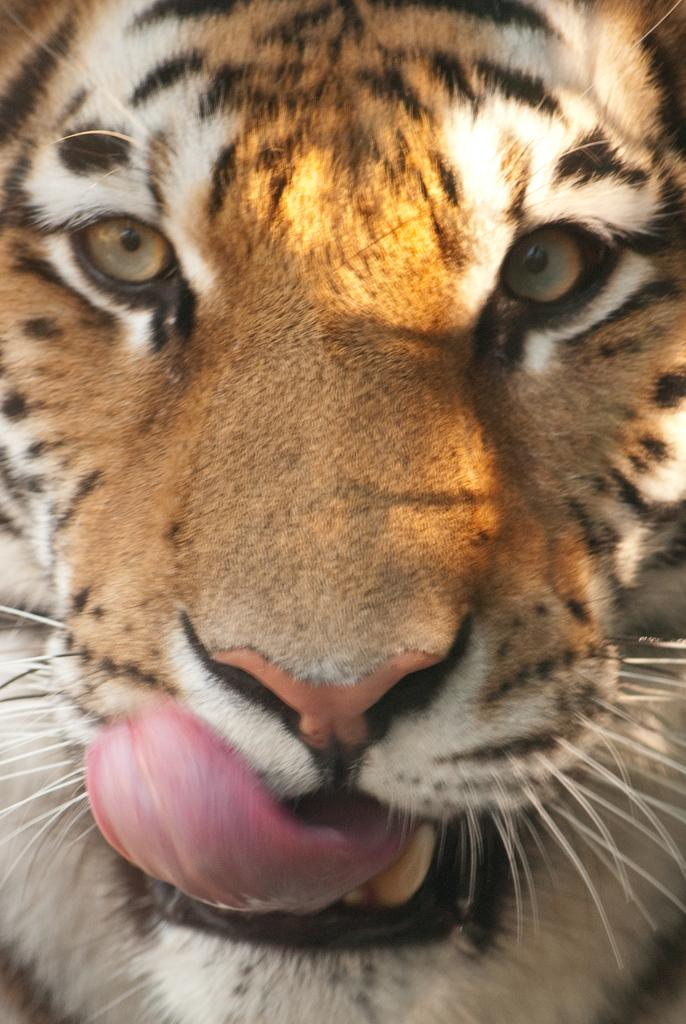What animal is present in the image? There is a tiger in the image. Can you describe the tiger's tongue in the image? The tiger has its tongue outside in the image. What type of quill is the tiger using to write a letter in the image? There is no quill or letter present in the image; the tiger is simply depicted with its tongue outside. What type of juice is the tiger drinking from a glass in the image? There is no juice or glass present in the image; the tiger is simply depicted with its tongue outside. 